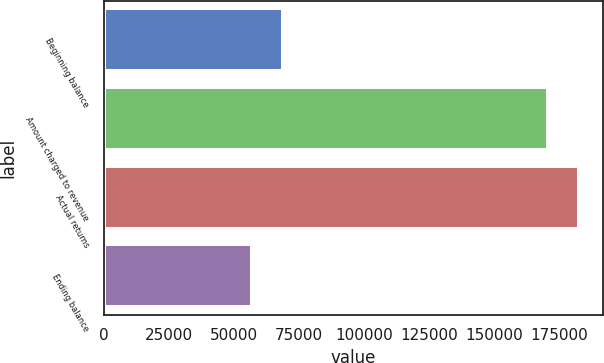Convert chart. <chart><loc_0><loc_0><loc_500><loc_500><bar_chart><fcel>Beginning balance<fcel>Amount charged to revenue<fcel>Actual returns<fcel>Ending balance<nl><fcel>68819<fcel>170839<fcel>182600<fcel>57058<nl></chart> 